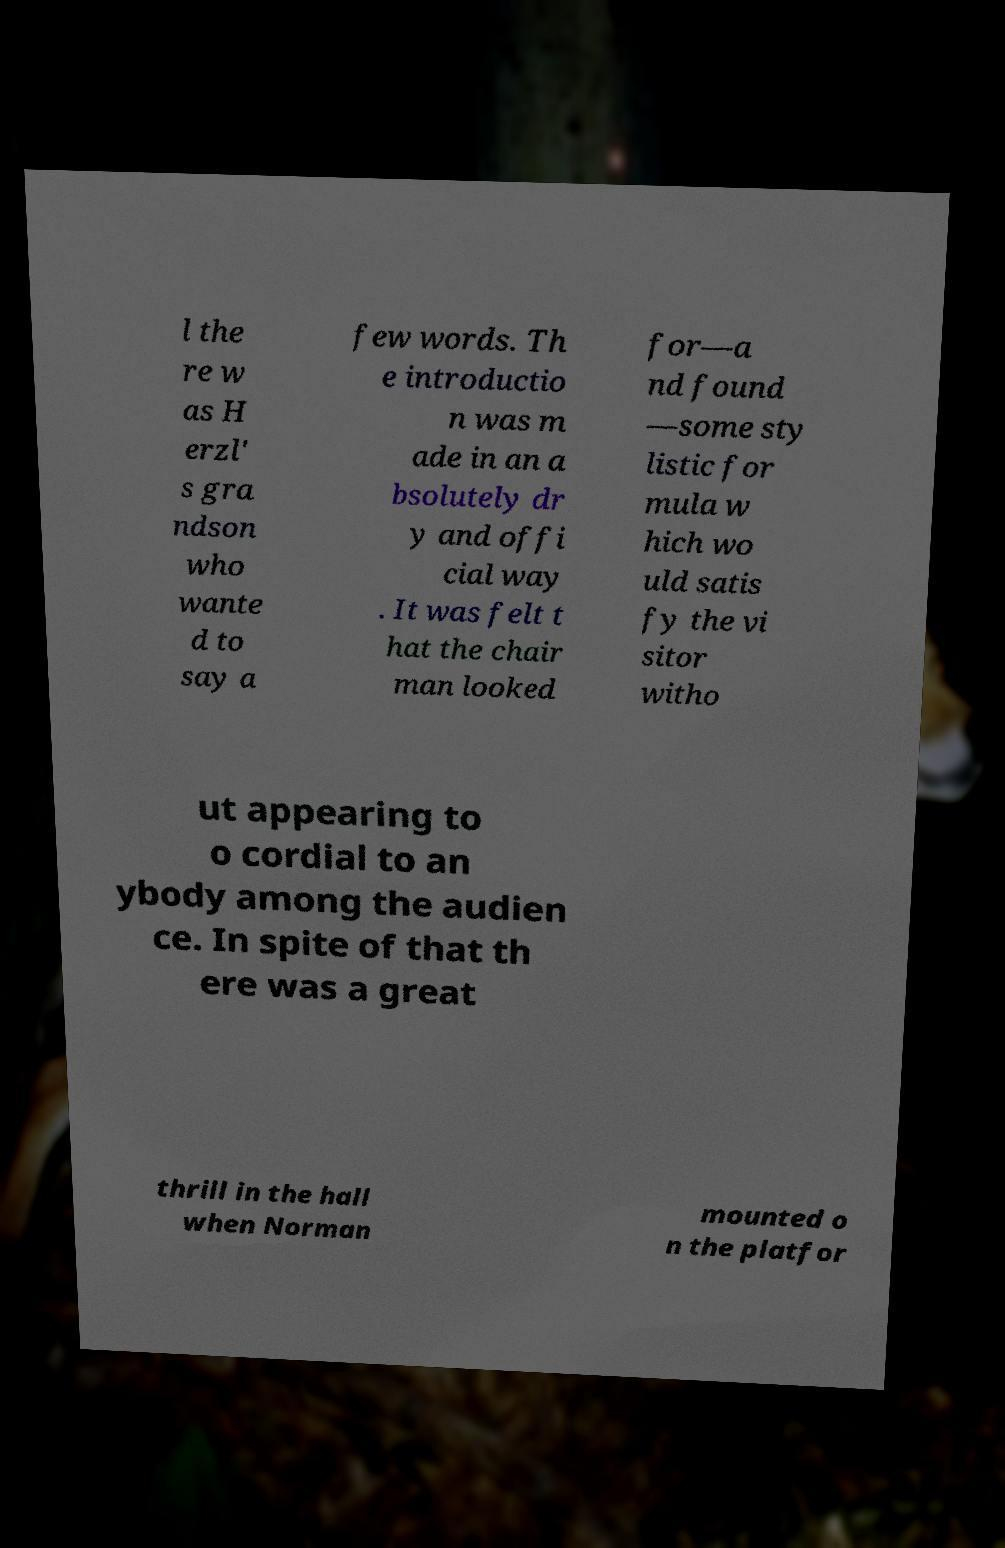Could you extract and type out the text from this image? l the re w as H erzl' s gra ndson who wante d to say a few words. Th e introductio n was m ade in an a bsolutely dr y and offi cial way . It was felt t hat the chair man looked for—a nd found —some sty listic for mula w hich wo uld satis fy the vi sitor witho ut appearing to o cordial to an ybody among the audien ce. In spite of that th ere was a great thrill in the hall when Norman mounted o n the platfor 